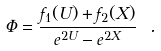Convert formula to latex. <formula><loc_0><loc_0><loc_500><loc_500>\Phi = \frac { f _ { 1 } ( U ) + f _ { 2 } ( X ) } { e ^ { 2 U } - e ^ { 2 X } } \ .</formula> 